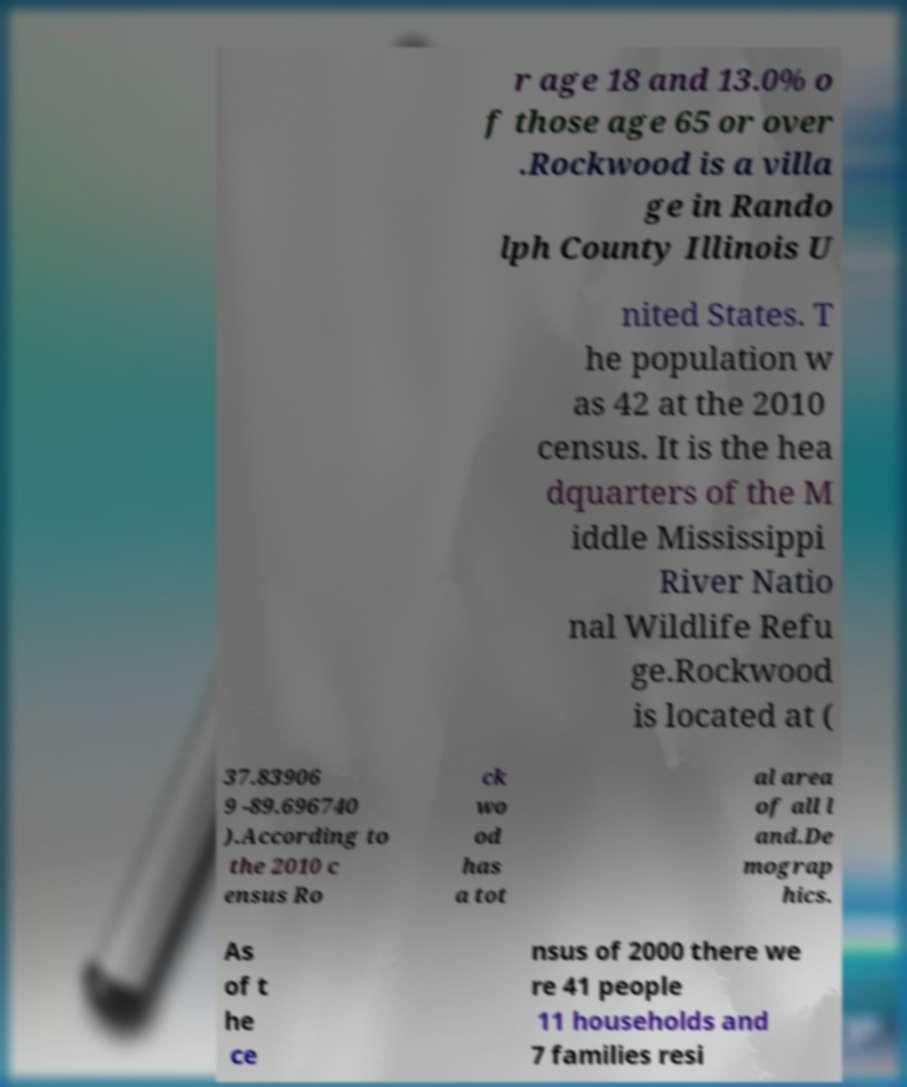Could you extract and type out the text from this image? r age 18 and 13.0% o f those age 65 or over .Rockwood is a villa ge in Rando lph County Illinois U nited States. T he population w as 42 at the 2010 census. It is the hea dquarters of the M iddle Mississippi River Natio nal Wildlife Refu ge.Rockwood is located at ( 37.83906 9 -89.696740 ).According to the 2010 c ensus Ro ck wo od has a tot al area of all l and.De mograp hics. As of t he ce nsus of 2000 there we re 41 people 11 households and 7 families resi 